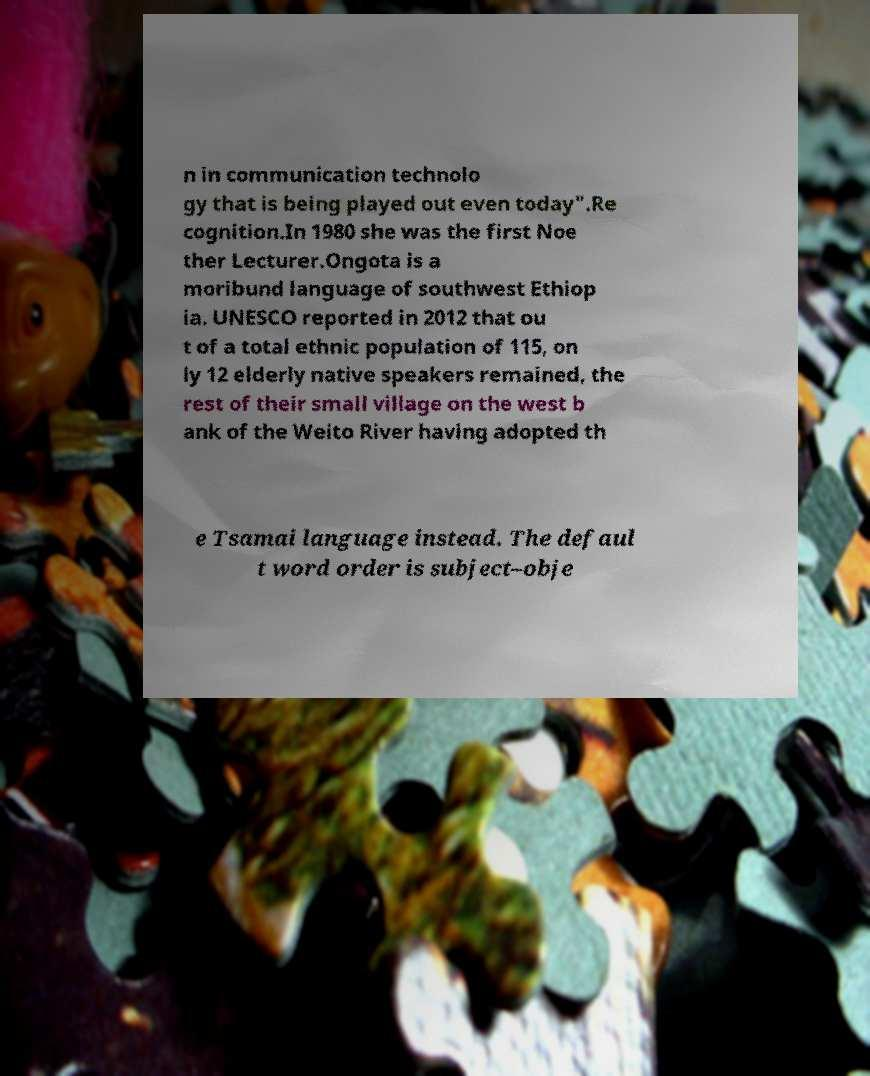Can you accurately transcribe the text from the provided image for me? n in communication technolo gy that is being played out even today".Re cognition.In 1980 she was the first Noe ther Lecturer.Ongota is a moribund language of southwest Ethiop ia. UNESCO reported in 2012 that ou t of a total ethnic population of 115, on ly 12 elderly native speakers remained, the rest of their small village on the west b ank of the Weito River having adopted th e Tsamai language instead. The defaul t word order is subject–obje 